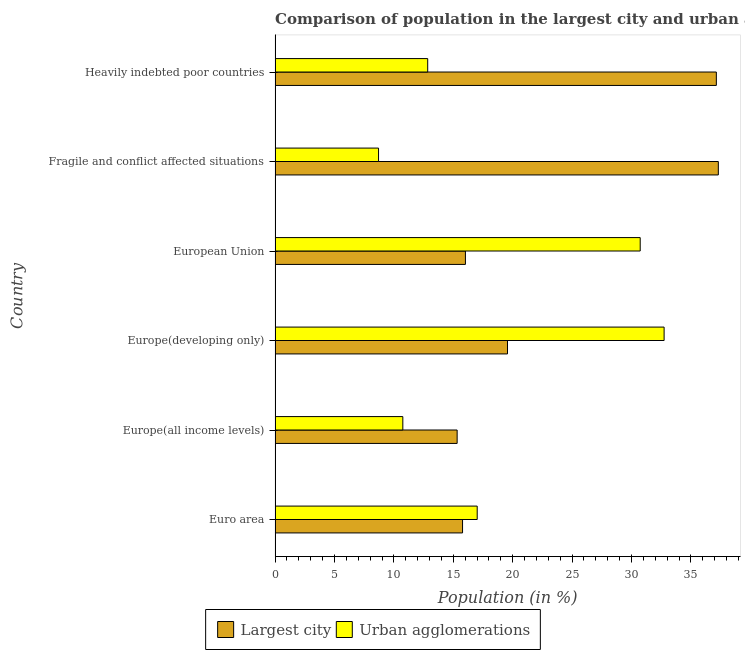How many different coloured bars are there?
Provide a succinct answer. 2. How many bars are there on the 4th tick from the bottom?
Your answer should be very brief. 2. What is the label of the 5th group of bars from the top?
Make the answer very short. Europe(all income levels). In how many cases, is the number of bars for a given country not equal to the number of legend labels?
Provide a short and direct response. 0. What is the population in the largest city in Euro area?
Ensure brevity in your answer.  15.78. Across all countries, what is the maximum population in urban agglomerations?
Offer a very short reply. 32.75. Across all countries, what is the minimum population in the largest city?
Provide a short and direct response. 15.32. In which country was the population in the largest city maximum?
Your answer should be very brief. Fragile and conflict affected situations. In which country was the population in urban agglomerations minimum?
Give a very brief answer. Fragile and conflict affected situations. What is the total population in the largest city in the graph?
Offer a terse response. 141.14. What is the difference between the population in the largest city in Euro area and that in European Union?
Provide a succinct answer. -0.24. What is the difference between the population in the largest city in Europe(developing only) and the population in urban agglomerations in European Union?
Your answer should be compact. -11.17. What is the average population in the largest city per country?
Give a very brief answer. 23.52. What is the difference between the population in urban agglomerations and population in the largest city in European Union?
Offer a very short reply. 14.71. In how many countries, is the population in urban agglomerations greater than 5 %?
Provide a succinct answer. 6. What is the ratio of the population in urban agglomerations in Europe(all income levels) to that in Europe(developing only)?
Your answer should be very brief. 0.33. Is the difference between the population in urban agglomerations in Europe(all income levels) and Europe(developing only) greater than the difference between the population in the largest city in Europe(all income levels) and Europe(developing only)?
Keep it short and to the point. No. What is the difference between the highest and the second highest population in the largest city?
Ensure brevity in your answer.  0.17. What is the difference between the highest and the lowest population in the largest city?
Provide a succinct answer. 21.99. In how many countries, is the population in the largest city greater than the average population in the largest city taken over all countries?
Ensure brevity in your answer.  2. What does the 2nd bar from the top in European Union represents?
Your response must be concise. Largest city. What does the 1st bar from the bottom in European Union represents?
Provide a short and direct response. Largest city. How many bars are there?
Keep it short and to the point. 12. How many countries are there in the graph?
Give a very brief answer. 6. Does the graph contain grids?
Provide a succinct answer. No. Where does the legend appear in the graph?
Give a very brief answer. Bottom center. How are the legend labels stacked?
Give a very brief answer. Horizontal. What is the title of the graph?
Keep it short and to the point. Comparison of population in the largest city and urban agglomerations in 1987. Does "Nonresident" appear as one of the legend labels in the graph?
Offer a terse response. No. What is the label or title of the Y-axis?
Provide a succinct answer. Country. What is the Population (in %) of Largest city in Euro area?
Make the answer very short. 15.78. What is the Population (in %) in Urban agglomerations in Euro area?
Keep it short and to the point. 17.01. What is the Population (in %) of Largest city in Europe(all income levels)?
Your answer should be very brief. 15.32. What is the Population (in %) of Urban agglomerations in Europe(all income levels)?
Your response must be concise. 10.75. What is the Population (in %) of Largest city in Europe(developing only)?
Your response must be concise. 19.56. What is the Population (in %) in Urban agglomerations in Europe(developing only)?
Ensure brevity in your answer.  32.75. What is the Population (in %) in Largest city in European Union?
Your answer should be very brief. 16.02. What is the Population (in %) of Urban agglomerations in European Union?
Keep it short and to the point. 30.73. What is the Population (in %) in Largest city in Fragile and conflict affected situations?
Keep it short and to the point. 37.31. What is the Population (in %) of Urban agglomerations in Fragile and conflict affected situations?
Provide a short and direct response. 8.71. What is the Population (in %) of Largest city in Heavily indebted poor countries?
Keep it short and to the point. 37.14. What is the Population (in %) in Urban agglomerations in Heavily indebted poor countries?
Provide a succinct answer. 12.85. Across all countries, what is the maximum Population (in %) in Largest city?
Keep it short and to the point. 37.31. Across all countries, what is the maximum Population (in %) of Urban agglomerations?
Your answer should be very brief. 32.75. Across all countries, what is the minimum Population (in %) of Largest city?
Your answer should be very brief. 15.32. Across all countries, what is the minimum Population (in %) in Urban agglomerations?
Provide a succinct answer. 8.71. What is the total Population (in %) of Largest city in the graph?
Your answer should be compact. 141.14. What is the total Population (in %) in Urban agglomerations in the graph?
Your answer should be very brief. 112.8. What is the difference between the Population (in %) of Largest city in Euro area and that in Europe(all income levels)?
Your answer should be compact. 0.46. What is the difference between the Population (in %) in Urban agglomerations in Euro area and that in Europe(all income levels)?
Make the answer very short. 6.26. What is the difference between the Population (in %) of Largest city in Euro area and that in Europe(developing only)?
Provide a short and direct response. -3.78. What is the difference between the Population (in %) in Urban agglomerations in Euro area and that in Europe(developing only)?
Provide a succinct answer. -15.73. What is the difference between the Population (in %) in Largest city in Euro area and that in European Union?
Provide a short and direct response. -0.24. What is the difference between the Population (in %) in Urban agglomerations in Euro area and that in European Union?
Make the answer very short. -13.72. What is the difference between the Population (in %) of Largest city in Euro area and that in Fragile and conflict affected situations?
Keep it short and to the point. -21.53. What is the difference between the Population (in %) of Urban agglomerations in Euro area and that in Fragile and conflict affected situations?
Offer a very short reply. 8.3. What is the difference between the Population (in %) of Largest city in Euro area and that in Heavily indebted poor countries?
Give a very brief answer. -21.36. What is the difference between the Population (in %) in Urban agglomerations in Euro area and that in Heavily indebted poor countries?
Ensure brevity in your answer.  4.17. What is the difference between the Population (in %) in Largest city in Europe(all income levels) and that in Europe(developing only)?
Ensure brevity in your answer.  -4.24. What is the difference between the Population (in %) of Urban agglomerations in Europe(all income levels) and that in Europe(developing only)?
Make the answer very short. -21.99. What is the difference between the Population (in %) of Largest city in Europe(all income levels) and that in European Union?
Make the answer very short. -0.7. What is the difference between the Population (in %) of Urban agglomerations in Europe(all income levels) and that in European Union?
Provide a succinct answer. -19.98. What is the difference between the Population (in %) in Largest city in Europe(all income levels) and that in Fragile and conflict affected situations?
Give a very brief answer. -21.99. What is the difference between the Population (in %) of Urban agglomerations in Europe(all income levels) and that in Fragile and conflict affected situations?
Provide a succinct answer. 2.04. What is the difference between the Population (in %) in Largest city in Europe(all income levels) and that in Heavily indebted poor countries?
Ensure brevity in your answer.  -21.82. What is the difference between the Population (in %) in Urban agglomerations in Europe(all income levels) and that in Heavily indebted poor countries?
Ensure brevity in your answer.  -2.09. What is the difference between the Population (in %) in Largest city in Europe(developing only) and that in European Union?
Offer a terse response. 3.54. What is the difference between the Population (in %) of Urban agglomerations in Europe(developing only) and that in European Union?
Provide a succinct answer. 2.01. What is the difference between the Population (in %) in Largest city in Europe(developing only) and that in Fragile and conflict affected situations?
Provide a short and direct response. -17.75. What is the difference between the Population (in %) of Urban agglomerations in Europe(developing only) and that in Fragile and conflict affected situations?
Ensure brevity in your answer.  24.04. What is the difference between the Population (in %) in Largest city in Europe(developing only) and that in Heavily indebted poor countries?
Your answer should be very brief. -17.58. What is the difference between the Population (in %) in Urban agglomerations in Europe(developing only) and that in Heavily indebted poor countries?
Ensure brevity in your answer.  19.9. What is the difference between the Population (in %) in Largest city in European Union and that in Fragile and conflict affected situations?
Offer a very short reply. -21.29. What is the difference between the Population (in %) of Urban agglomerations in European Union and that in Fragile and conflict affected situations?
Ensure brevity in your answer.  22.03. What is the difference between the Population (in %) of Largest city in European Union and that in Heavily indebted poor countries?
Make the answer very short. -21.12. What is the difference between the Population (in %) in Urban agglomerations in European Union and that in Heavily indebted poor countries?
Your answer should be compact. 17.89. What is the difference between the Population (in %) of Largest city in Fragile and conflict affected situations and that in Heavily indebted poor countries?
Your answer should be very brief. 0.17. What is the difference between the Population (in %) of Urban agglomerations in Fragile and conflict affected situations and that in Heavily indebted poor countries?
Provide a succinct answer. -4.14. What is the difference between the Population (in %) of Largest city in Euro area and the Population (in %) of Urban agglomerations in Europe(all income levels)?
Keep it short and to the point. 5.03. What is the difference between the Population (in %) of Largest city in Euro area and the Population (in %) of Urban agglomerations in Europe(developing only)?
Ensure brevity in your answer.  -16.97. What is the difference between the Population (in %) of Largest city in Euro area and the Population (in %) of Urban agglomerations in European Union?
Make the answer very short. -14.95. What is the difference between the Population (in %) in Largest city in Euro area and the Population (in %) in Urban agglomerations in Fragile and conflict affected situations?
Provide a short and direct response. 7.07. What is the difference between the Population (in %) of Largest city in Euro area and the Population (in %) of Urban agglomerations in Heavily indebted poor countries?
Your answer should be compact. 2.93. What is the difference between the Population (in %) of Largest city in Europe(all income levels) and the Population (in %) of Urban agglomerations in Europe(developing only)?
Offer a very short reply. -17.42. What is the difference between the Population (in %) in Largest city in Europe(all income levels) and the Population (in %) in Urban agglomerations in European Union?
Provide a succinct answer. -15.41. What is the difference between the Population (in %) in Largest city in Europe(all income levels) and the Population (in %) in Urban agglomerations in Fragile and conflict affected situations?
Provide a succinct answer. 6.61. What is the difference between the Population (in %) in Largest city in Europe(all income levels) and the Population (in %) in Urban agglomerations in Heavily indebted poor countries?
Provide a succinct answer. 2.48. What is the difference between the Population (in %) of Largest city in Europe(developing only) and the Population (in %) of Urban agglomerations in European Union?
Provide a short and direct response. -11.17. What is the difference between the Population (in %) of Largest city in Europe(developing only) and the Population (in %) of Urban agglomerations in Fragile and conflict affected situations?
Provide a succinct answer. 10.85. What is the difference between the Population (in %) of Largest city in Europe(developing only) and the Population (in %) of Urban agglomerations in Heavily indebted poor countries?
Offer a terse response. 6.72. What is the difference between the Population (in %) in Largest city in European Union and the Population (in %) in Urban agglomerations in Fragile and conflict affected situations?
Give a very brief answer. 7.31. What is the difference between the Population (in %) of Largest city in European Union and the Population (in %) of Urban agglomerations in Heavily indebted poor countries?
Keep it short and to the point. 3.17. What is the difference between the Population (in %) of Largest city in Fragile and conflict affected situations and the Population (in %) of Urban agglomerations in Heavily indebted poor countries?
Keep it short and to the point. 24.46. What is the average Population (in %) in Largest city per country?
Your answer should be very brief. 23.52. What is the average Population (in %) in Urban agglomerations per country?
Make the answer very short. 18.8. What is the difference between the Population (in %) of Largest city and Population (in %) of Urban agglomerations in Euro area?
Your response must be concise. -1.23. What is the difference between the Population (in %) of Largest city and Population (in %) of Urban agglomerations in Europe(all income levels)?
Keep it short and to the point. 4.57. What is the difference between the Population (in %) of Largest city and Population (in %) of Urban agglomerations in Europe(developing only)?
Your answer should be compact. -13.18. What is the difference between the Population (in %) of Largest city and Population (in %) of Urban agglomerations in European Union?
Give a very brief answer. -14.71. What is the difference between the Population (in %) of Largest city and Population (in %) of Urban agglomerations in Fragile and conflict affected situations?
Give a very brief answer. 28.6. What is the difference between the Population (in %) in Largest city and Population (in %) in Urban agglomerations in Heavily indebted poor countries?
Provide a short and direct response. 24.3. What is the ratio of the Population (in %) in Largest city in Euro area to that in Europe(all income levels)?
Provide a succinct answer. 1.03. What is the ratio of the Population (in %) in Urban agglomerations in Euro area to that in Europe(all income levels)?
Your answer should be compact. 1.58. What is the ratio of the Population (in %) in Largest city in Euro area to that in Europe(developing only)?
Ensure brevity in your answer.  0.81. What is the ratio of the Population (in %) of Urban agglomerations in Euro area to that in Europe(developing only)?
Your response must be concise. 0.52. What is the ratio of the Population (in %) of Largest city in Euro area to that in European Union?
Offer a terse response. 0.98. What is the ratio of the Population (in %) of Urban agglomerations in Euro area to that in European Union?
Give a very brief answer. 0.55. What is the ratio of the Population (in %) of Largest city in Euro area to that in Fragile and conflict affected situations?
Offer a terse response. 0.42. What is the ratio of the Population (in %) in Urban agglomerations in Euro area to that in Fragile and conflict affected situations?
Provide a succinct answer. 1.95. What is the ratio of the Population (in %) of Largest city in Euro area to that in Heavily indebted poor countries?
Your response must be concise. 0.42. What is the ratio of the Population (in %) in Urban agglomerations in Euro area to that in Heavily indebted poor countries?
Provide a short and direct response. 1.32. What is the ratio of the Population (in %) in Largest city in Europe(all income levels) to that in Europe(developing only)?
Your answer should be compact. 0.78. What is the ratio of the Population (in %) in Urban agglomerations in Europe(all income levels) to that in Europe(developing only)?
Your answer should be compact. 0.33. What is the ratio of the Population (in %) in Largest city in Europe(all income levels) to that in European Union?
Provide a succinct answer. 0.96. What is the ratio of the Population (in %) in Urban agglomerations in Europe(all income levels) to that in European Union?
Your answer should be very brief. 0.35. What is the ratio of the Population (in %) in Largest city in Europe(all income levels) to that in Fragile and conflict affected situations?
Offer a very short reply. 0.41. What is the ratio of the Population (in %) of Urban agglomerations in Europe(all income levels) to that in Fragile and conflict affected situations?
Provide a succinct answer. 1.23. What is the ratio of the Population (in %) in Largest city in Europe(all income levels) to that in Heavily indebted poor countries?
Your response must be concise. 0.41. What is the ratio of the Population (in %) of Urban agglomerations in Europe(all income levels) to that in Heavily indebted poor countries?
Your answer should be very brief. 0.84. What is the ratio of the Population (in %) in Largest city in Europe(developing only) to that in European Union?
Give a very brief answer. 1.22. What is the ratio of the Population (in %) of Urban agglomerations in Europe(developing only) to that in European Union?
Make the answer very short. 1.07. What is the ratio of the Population (in %) in Largest city in Europe(developing only) to that in Fragile and conflict affected situations?
Your response must be concise. 0.52. What is the ratio of the Population (in %) of Urban agglomerations in Europe(developing only) to that in Fragile and conflict affected situations?
Your response must be concise. 3.76. What is the ratio of the Population (in %) of Largest city in Europe(developing only) to that in Heavily indebted poor countries?
Make the answer very short. 0.53. What is the ratio of the Population (in %) in Urban agglomerations in Europe(developing only) to that in Heavily indebted poor countries?
Provide a short and direct response. 2.55. What is the ratio of the Population (in %) in Largest city in European Union to that in Fragile and conflict affected situations?
Ensure brevity in your answer.  0.43. What is the ratio of the Population (in %) of Urban agglomerations in European Union to that in Fragile and conflict affected situations?
Offer a terse response. 3.53. What is the ratio of the Population (in %) of Largest city in European Union to that in Heavily indebted poor countries?
Provide a succinct answer. 0.43. What is the ratio of the Population (in %) in Urban agglomerations in European Union to that in Heavily indebted poor countries?
Give a very brief answer. 2.39. What is the ratio of the Population (in %) in Largest city in Fragile and conflict affected situations to that in Heavily indebted poor countries?
Make the answer very short. 1. What is the ratio of the Population (in %) of Urban agglomerations in Fragile and conflict affected situations to that in Heavily indebted poor countries?
Keep it short and to the point. 0.68. What is the difference between the highest and the second highest Population (in %) of Largest city?
Your answer should be compact. 0.17. What is the difference between the highest and the second highest Population (in %) in Urban agglomerations?
Make the answer very short. 2.01. What is the difference between the highest and the lowest Population (in %) in Largest city?
Offer a terse response. 21.99. What is the difference between the highest and the lowest Population (in %) of Urban agglomerations?
Provide a succinct answer. 24.04. 